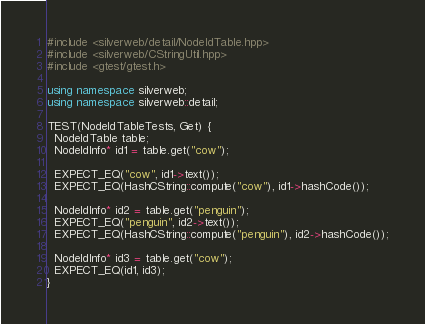<code> <loc_0><loc_0><loc_500><loc_500><_C++_>#include <silverweb/detail/NodeIdTable.hpp>
#include <silverweb/CStringUtil.hpp>
#include <gtest/gtest.h>

using namespace silverweb;
using namespace silverweb::detail;

TEST(NodeIdTableTests, Get) {
  NodeIdTable table;
  NodeIdInfo* id1 = table.get("cow");

  EXPECT_EQ("cow", id1->text());
  EXPECT_EQ(HashCString::compute("cow"), id1->hashCode());

  NodeIdInfo* id2 = table.get("penguin");
  EXPECT_EQ("penguin", id2->text());
  EXPECT_EQ(HashCString::compute("penguin"), id2->hashCode());

  NodeIdInfo* id3 = table.get("cow");
  EXPECT_EQ(id1, id3);
}

</code> 